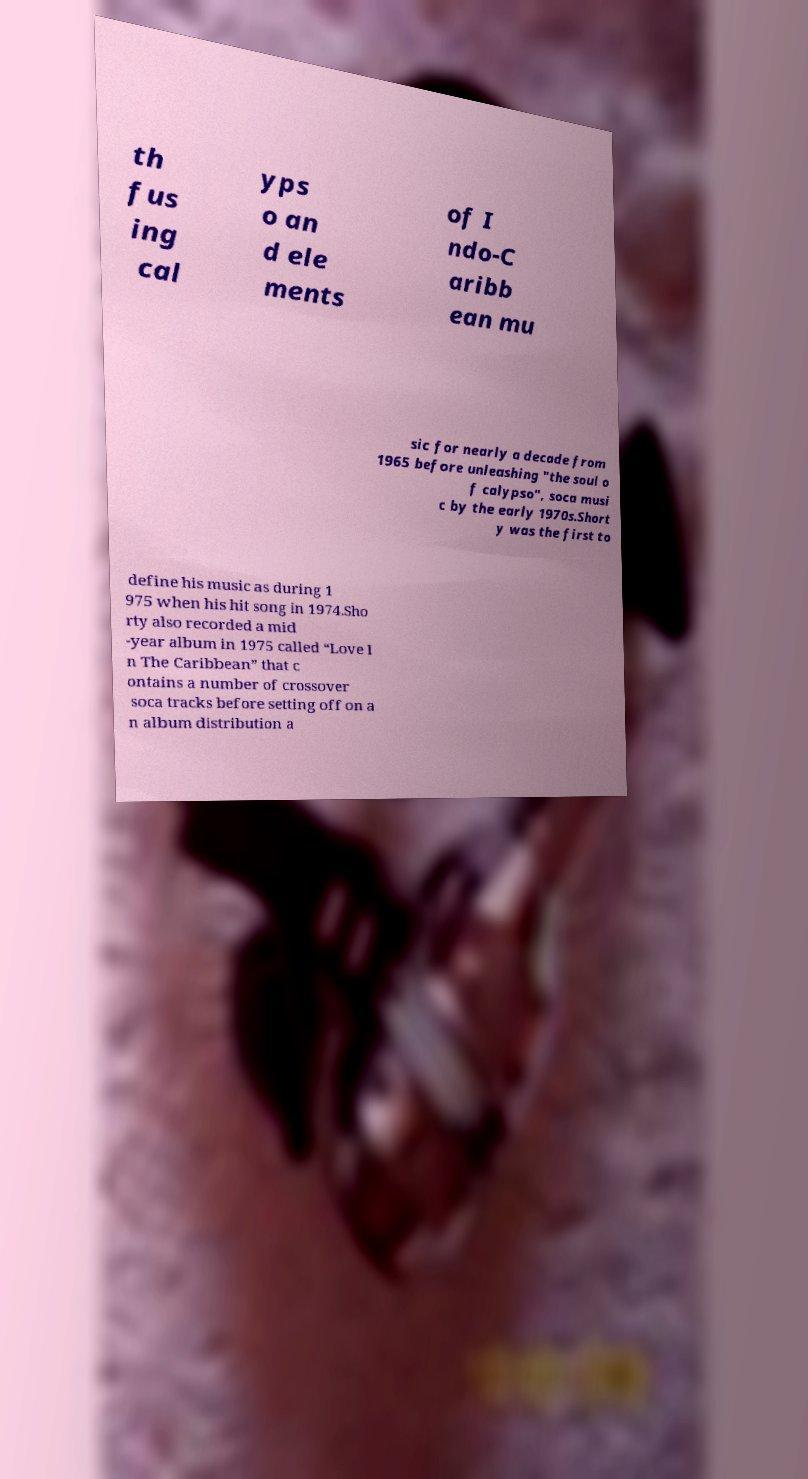What messages or text are displayed in this image? I need them in a readable, typed format. th fus ing cal yps o an d ele ments of I ndo-C aribb ean mu sic for nearly a decade from 1965 before unleashing "the soul o f calypso", soca musi c by the early 1970s.Short y was the first to define his music as during 1 975 when his hit song in 1974.Sho rty also recorded a mid -year album in 1975 called “Love I n The Caribbean” that c ontains a number of crossover soca tracks before setting off on a n album distribution a 